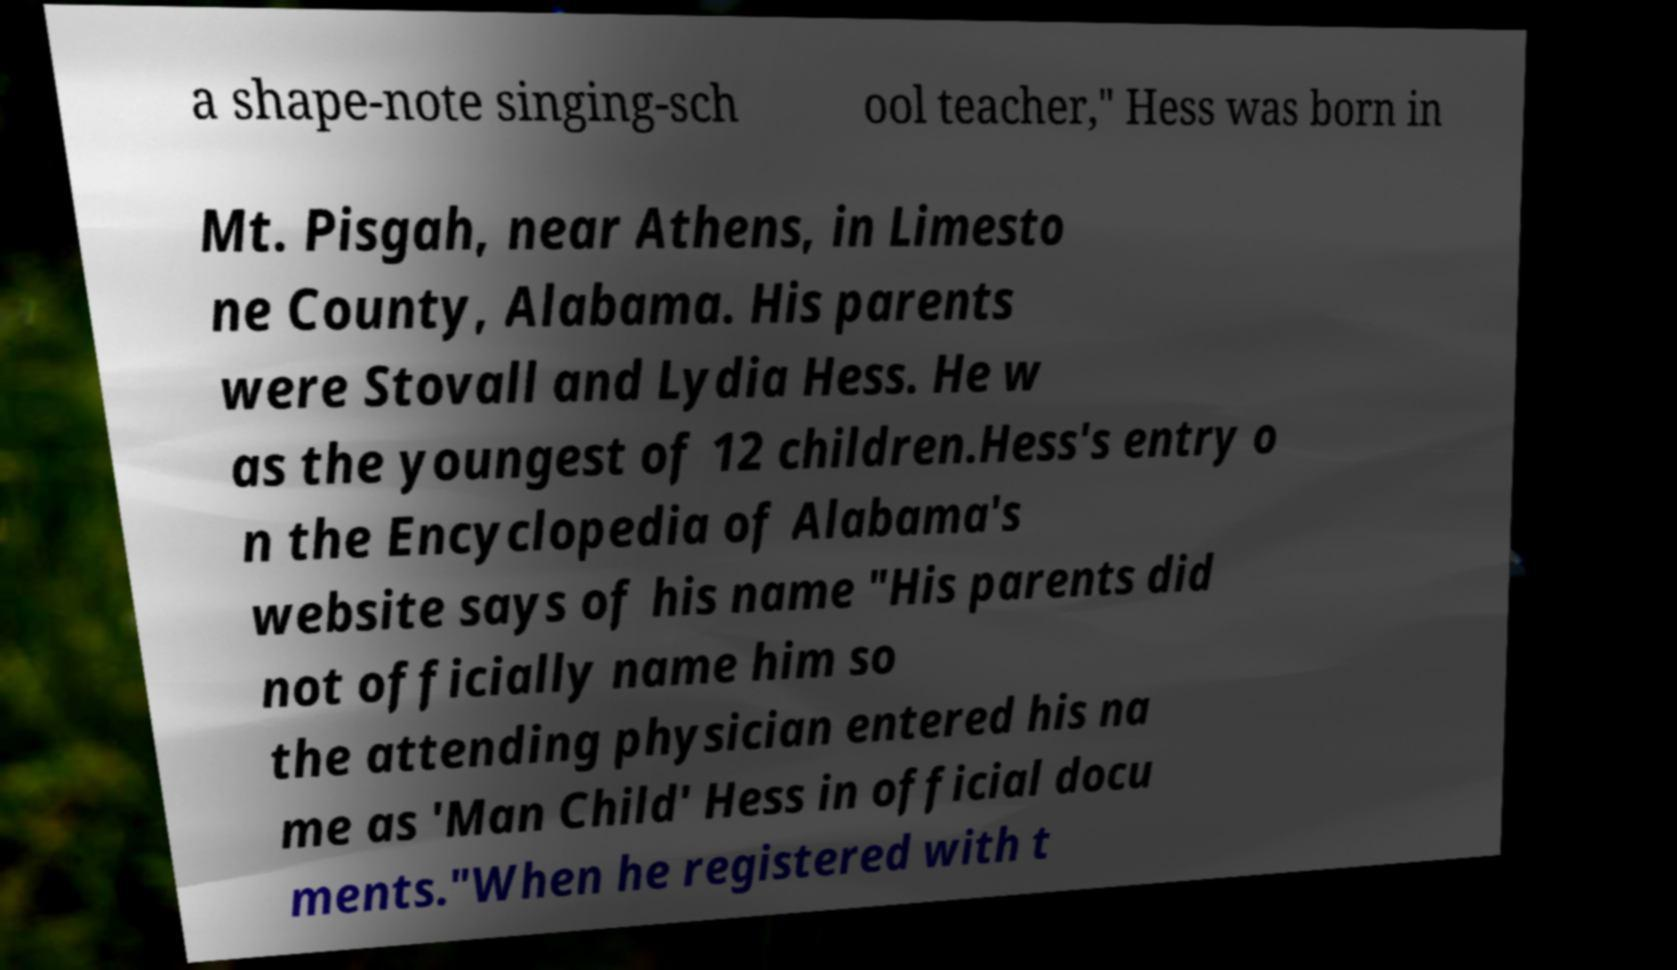Can you accurately transcribe the text from the provided image for me? a shape-note singing-sch ool teacher," Hess was born in Mt. Pisgah, near Athens, in Limesto ne County, Alabama. His parents were Stovall and Lydia Hess. He w as the youngest of 12 children.Hess's entry o n the Encyclopedia of Alabama's website says of his name "His parents did not officially name him so the attending physician entered his na me as 'Man Child' Hess in official docu ments."When he registered with t 